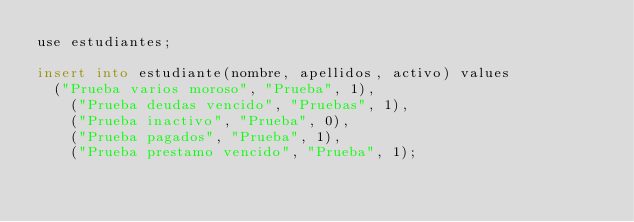<code> <loc_0><loc_0><loc_500><loc_500><_SQL_>use estudiantes;

insert into estudiante(nombre, apellidos, activo) values
	("Prueba varios moroso", "Prueba", 1),
    ("Prueba deudas vencido", "Pruebas", 1),
    ("Prueba inactivo", "Prueba", 0),
    ("Prueba pagados", "Prueba", 1),
    ("Prueba prestamo vencido", "Prueba", 1);
    </code> 